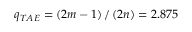Convert formula to latex. <formula><loc_0><loc_0><loc_500><loc_500>q _ { T A E } = \left ( 2 m - 1 \right ) / \left ( 2 n \right ) = 2 . 8 7 5</formula> 